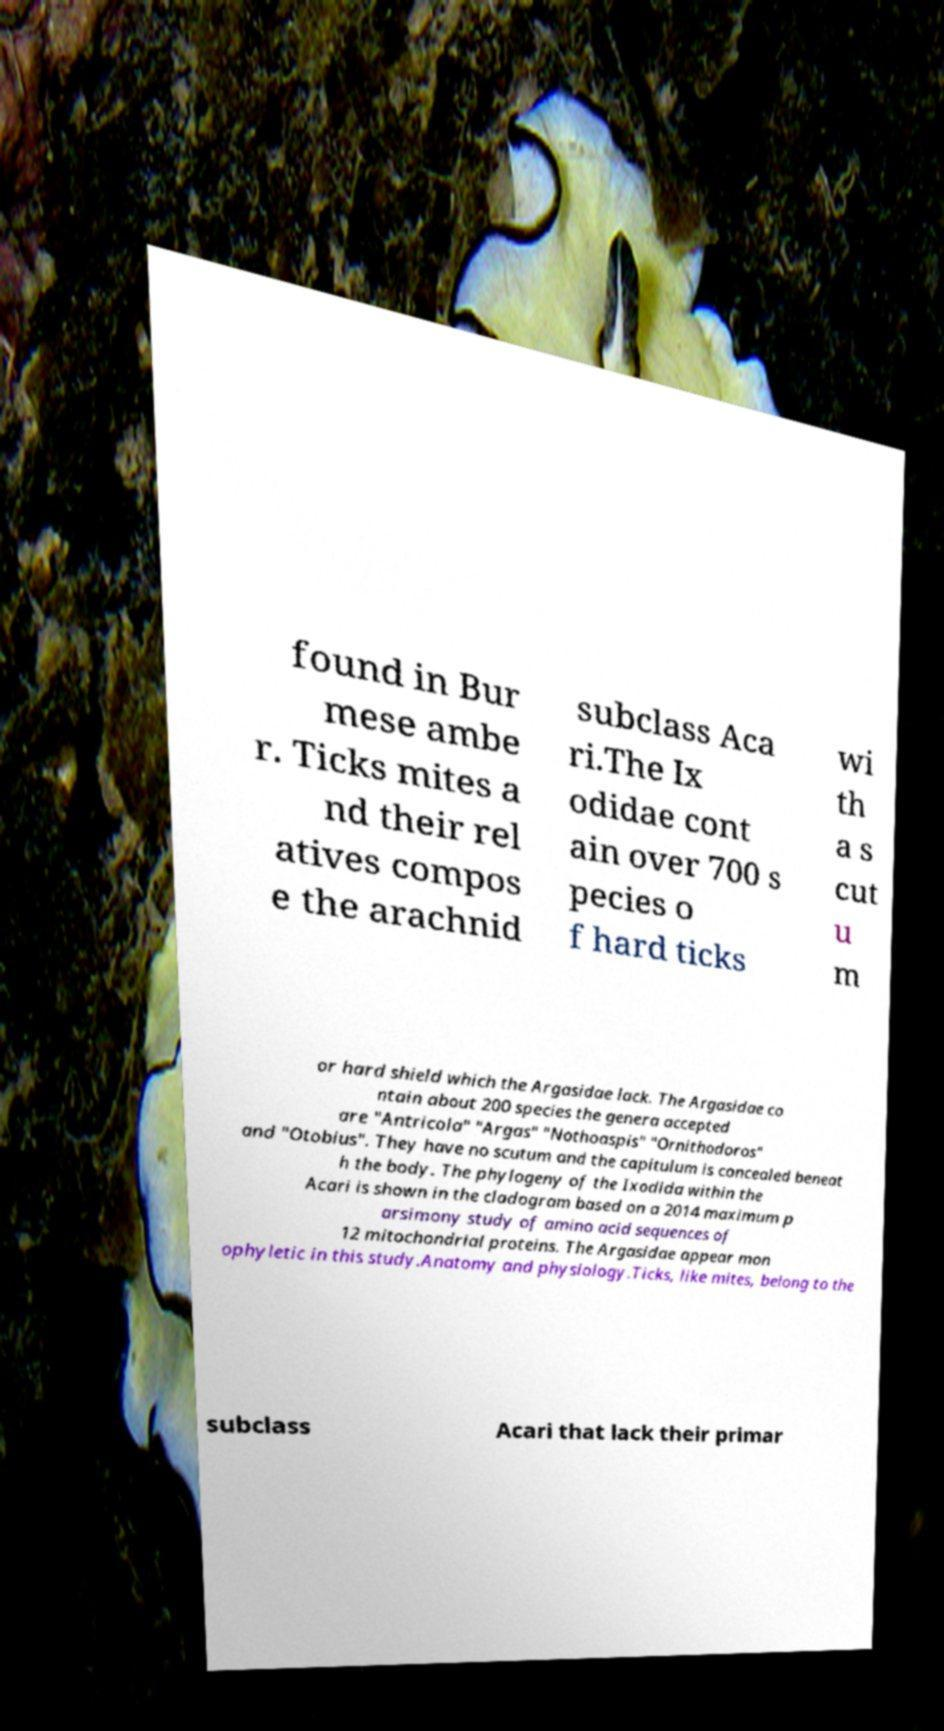Please identify and transcribe the text found in this image. found in Bur mese ambe r. Ticks mites a nd their rel atives compos e the arachnid subclass Aca ri.The Ix odidae cont ain over 700 s pecies o f hard ticks wi th a s cut u m or hard shield which the Argasidae lack. The Argasidae co ntain about 200 species the genera accepted are "Antricola" "Argas" "Nothoaspis" "Ornithodoros" and "Otobius". They have no scutum and the capitulum is concealed beneat h the body. The phylogeny of the Ixodida within the Acari is shown in the cladogram based on a 2014 maximum p arsimony study of amino acid sequences of 12 mitochondrial proteins. The Argasidae appear mon ophyletic in this study.Anatomy and physiology.Ticks, like mites, belong to the subclass Acari that lack their primar 